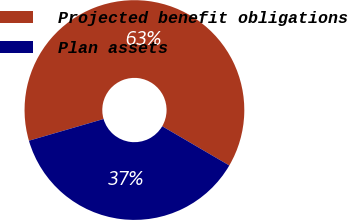<chart> <loc_0><loc_0><loc_500><loc_500><pie_chart><fcel>Projected benefit obligations<fcel>Plan assets<nl><fcel>62.92%<fcel>37.08%<nl></chart> 